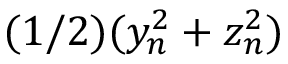Convert formula to latex. <formula><loc_0><loc_0><loc_500><loc_500>( 1 / 2 ) ( y _ { n } ^ { 2 } + z _ { n } ^ { 2 } )</formula> 